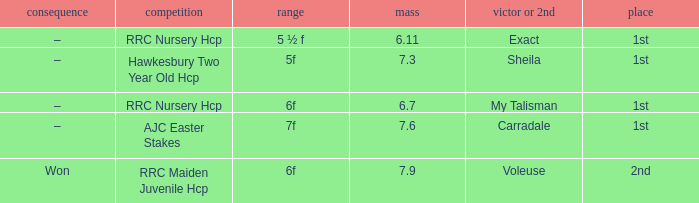What was the distance when the weight was 6.11? 5 ½ f. 